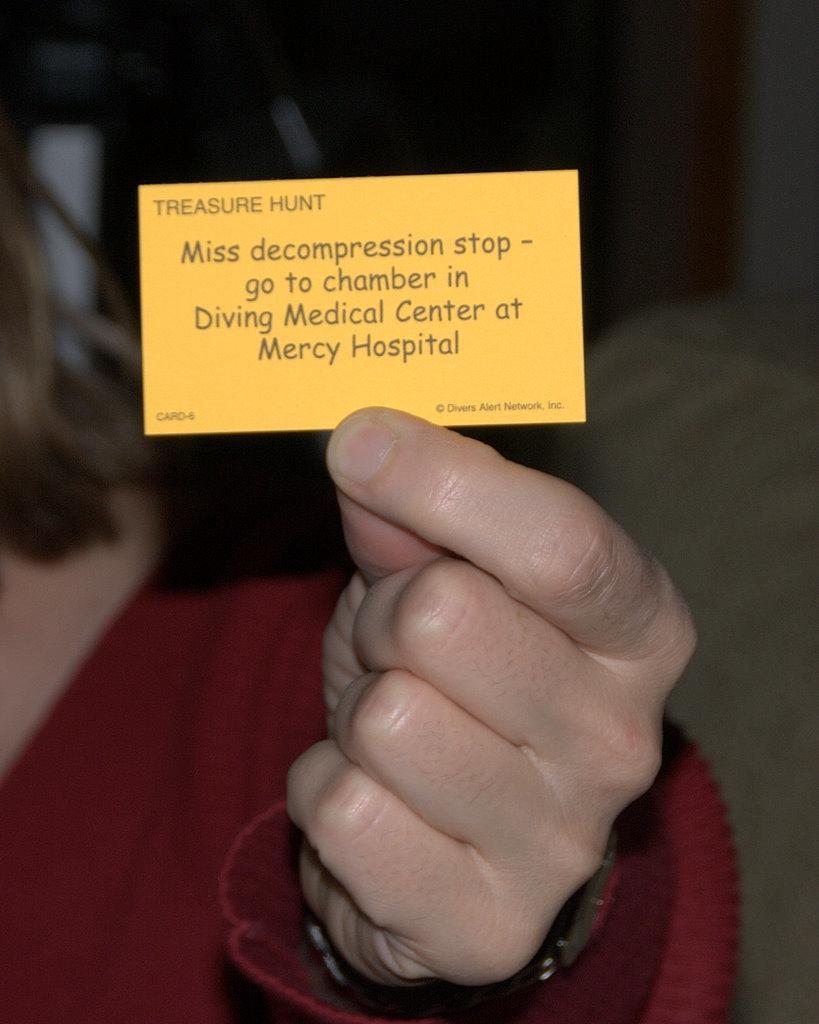In one or two sentences, can you explain what this image depicts? In this image we can see a person holding a card in her hand. 